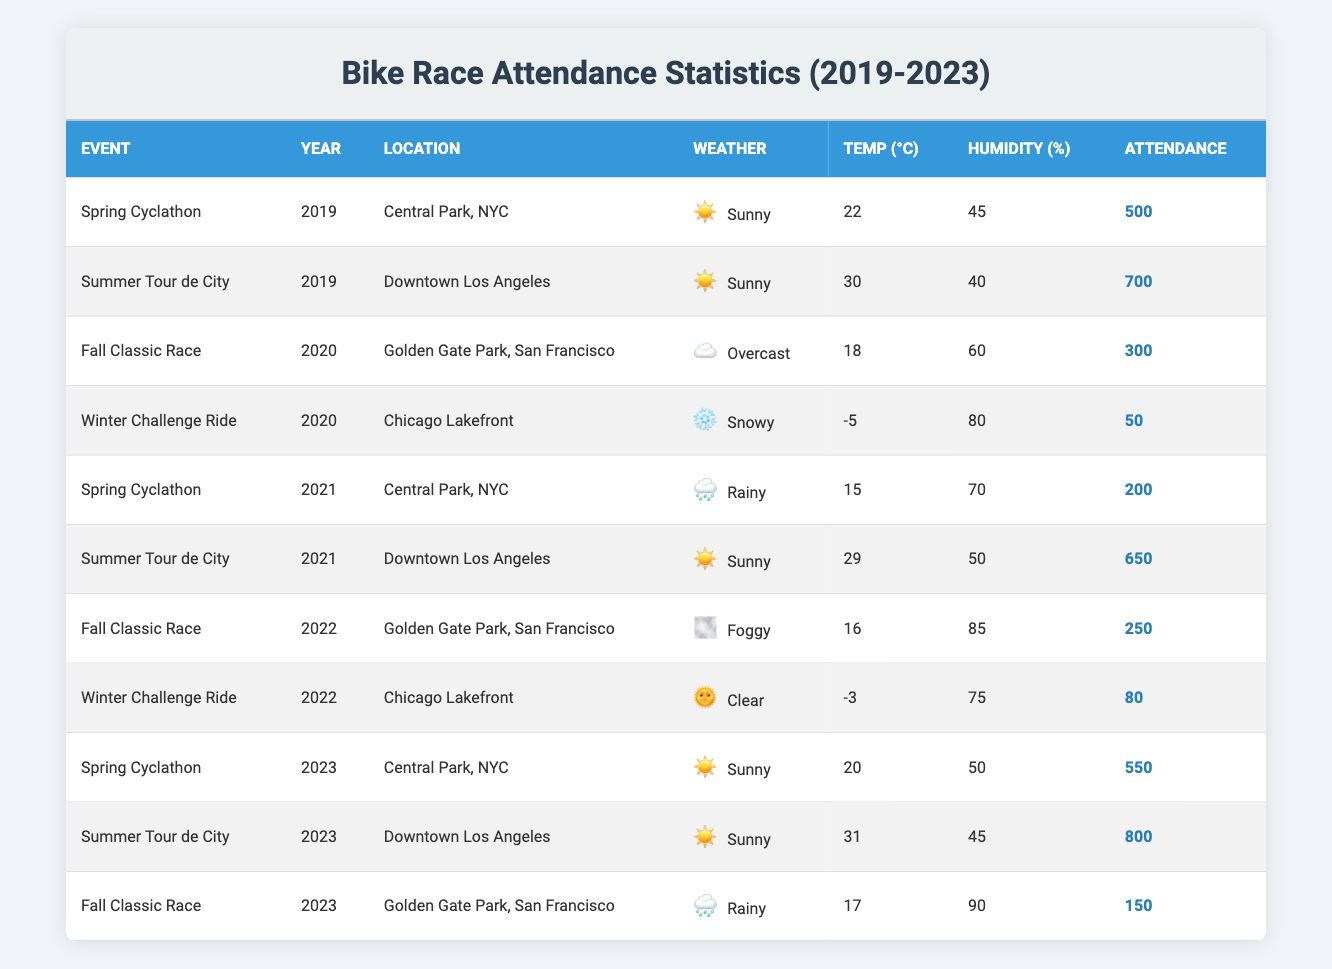What was the attendance for the Summer Tour de City in 2023? The table lists the attendance for each event, and it shows that the Summer Tour de City in 2023 has an attendance of 800.
Answer: 800 Which event had the lowest attendance in 2020? By inspecting the attendance figures for events in 2020, the lowest attendance recorded is 50 for the Winter Challenge Ride.
Answer: 50 Was the weather condition during the Winter Challenge Ride in 2022 clear? The table indicates that the Winter Challenge Ride in 2022 had clear weather. Thus, the answer is yes.
Answer: Yes How does the average attendance for the Spring Cyclathon compare between 2019 and 2023? The attendance figures for the Spring Cyclathon are 500 in 2019 and 550 in 2023. The average is calculated as (500 + 550) / 2 = 525.
Answer: 525 Which year had the highest recorded attendance overall? By reviewing the attendance figures for all events across years, the highest attendance was 800 during the Summer Tour de City in 2023.
Answer: 2023 Did any event in 2021 have an attendance over 600? Checking the attendance for events in 2021, only the Summer Tour de City had an attendance of 650, which is over 600. Therefore, the answer is yes.
Answer: Yes What was the temperature during the Fall Classic Race in 2022? The table shows that the temperature during the Fall Classic Race in 2022 was 16°C.
Answer: 16°C What is the difference in attendance between the Summer Tour de City in 2019 and the Summer Tour de City in 2021? For 2019, the attendance was 700, and for 2021, it was 650. The difference is 700 - 650 = 50.
Answer: 50 In which year and location did the event with the most humid conditions take place? The event with the most humidity was the Fall Classic Race in 2023, with 90% humidity in Golden Gate Park, San Francisco.
Answer: 2023, Golden Gate Park, San Francisco 